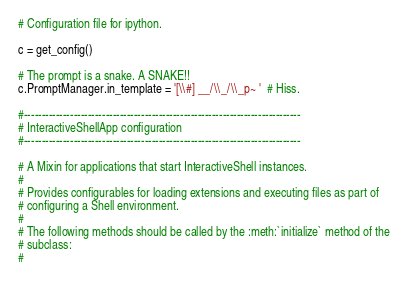<code> <loc_0><loc_0><loc_500><loc_500><_Python_># Configuration file for ipython.

c = get_config()

# The prompt is a snake. A SNAKE!!
c.PromptManager.in_template = '[\\#] __/\\_/\\_p~ '  # Hiss.

#------------------------------------------------------------------------------
# InteractiveShellApp configuration
#------------------------------------------------------------------------------

# A Mixin for applications that start InteractiveShell instances.
# 
# Provides configurables for loading extensions and executing files as part of
# configuring a Shell environment.
# 
# The following methods should be called by the :meth:`initialize` method of the
# subclass:
# </code> 